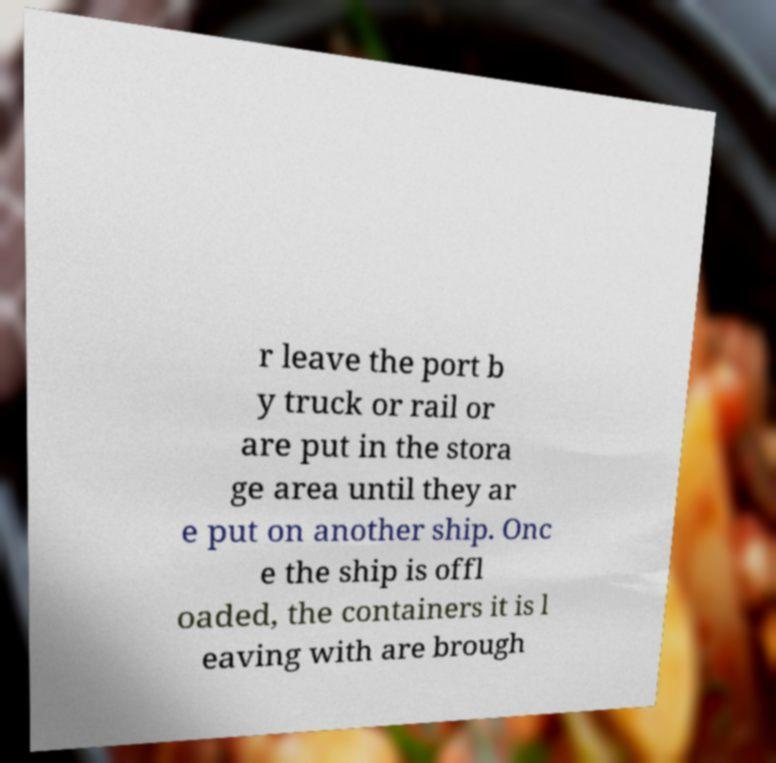Please identify and transcribe the text found in this image. r leave the port b y truck or rail or are put in the stora ge area until they ar e put on another ship. Onc e the ship is offl oaded, the containers it is l eaving with are brough 